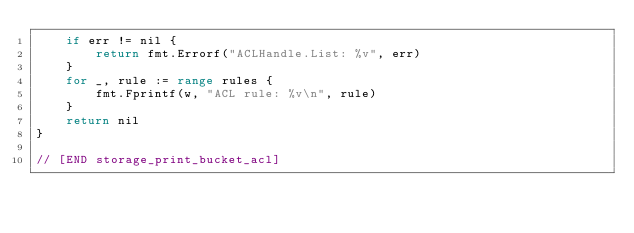Convert code to text. <code><loc_0><loc_0><loc_500><loc_500><_Go_>	if err != nil {
		return fmt.Errorf("ACLHandle.List: %v", err)
	}
	for _, rule := range rules {
		fmt.Fprintf(w, "ACL rule: %v\n", rule)
	}
	return nil
}

// [END storage_print_bucket_acl]
</code> 